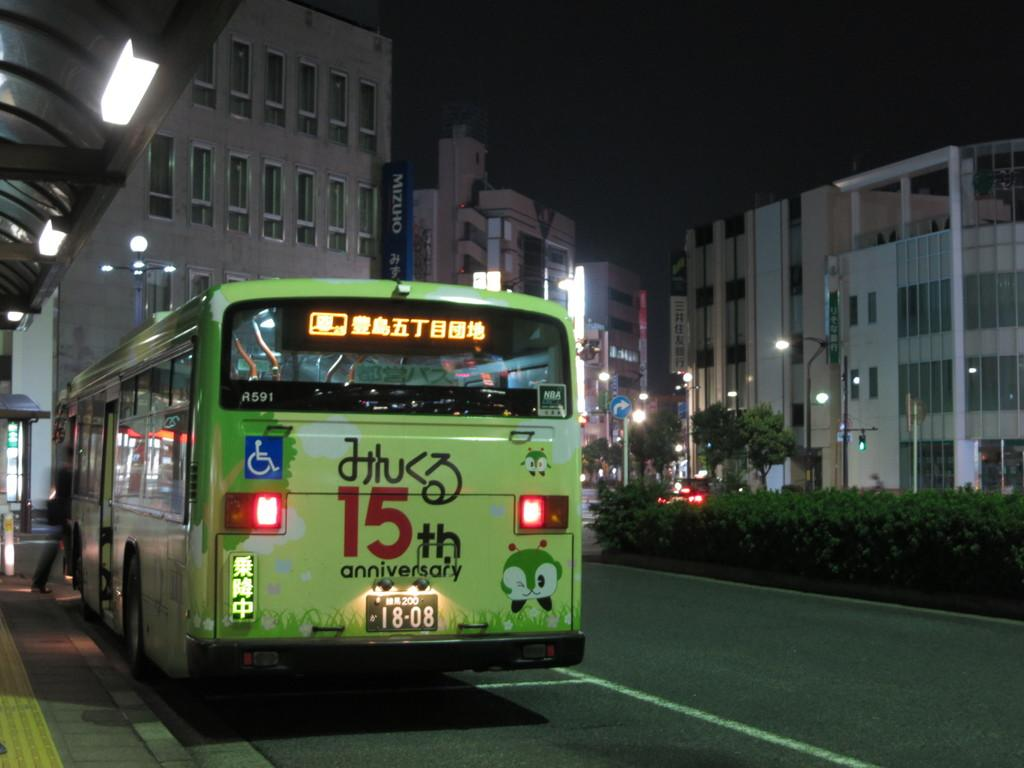<image>
Share a concise interpretation of the image provided. Number 15 is written on the back of the bus in the foreground. 